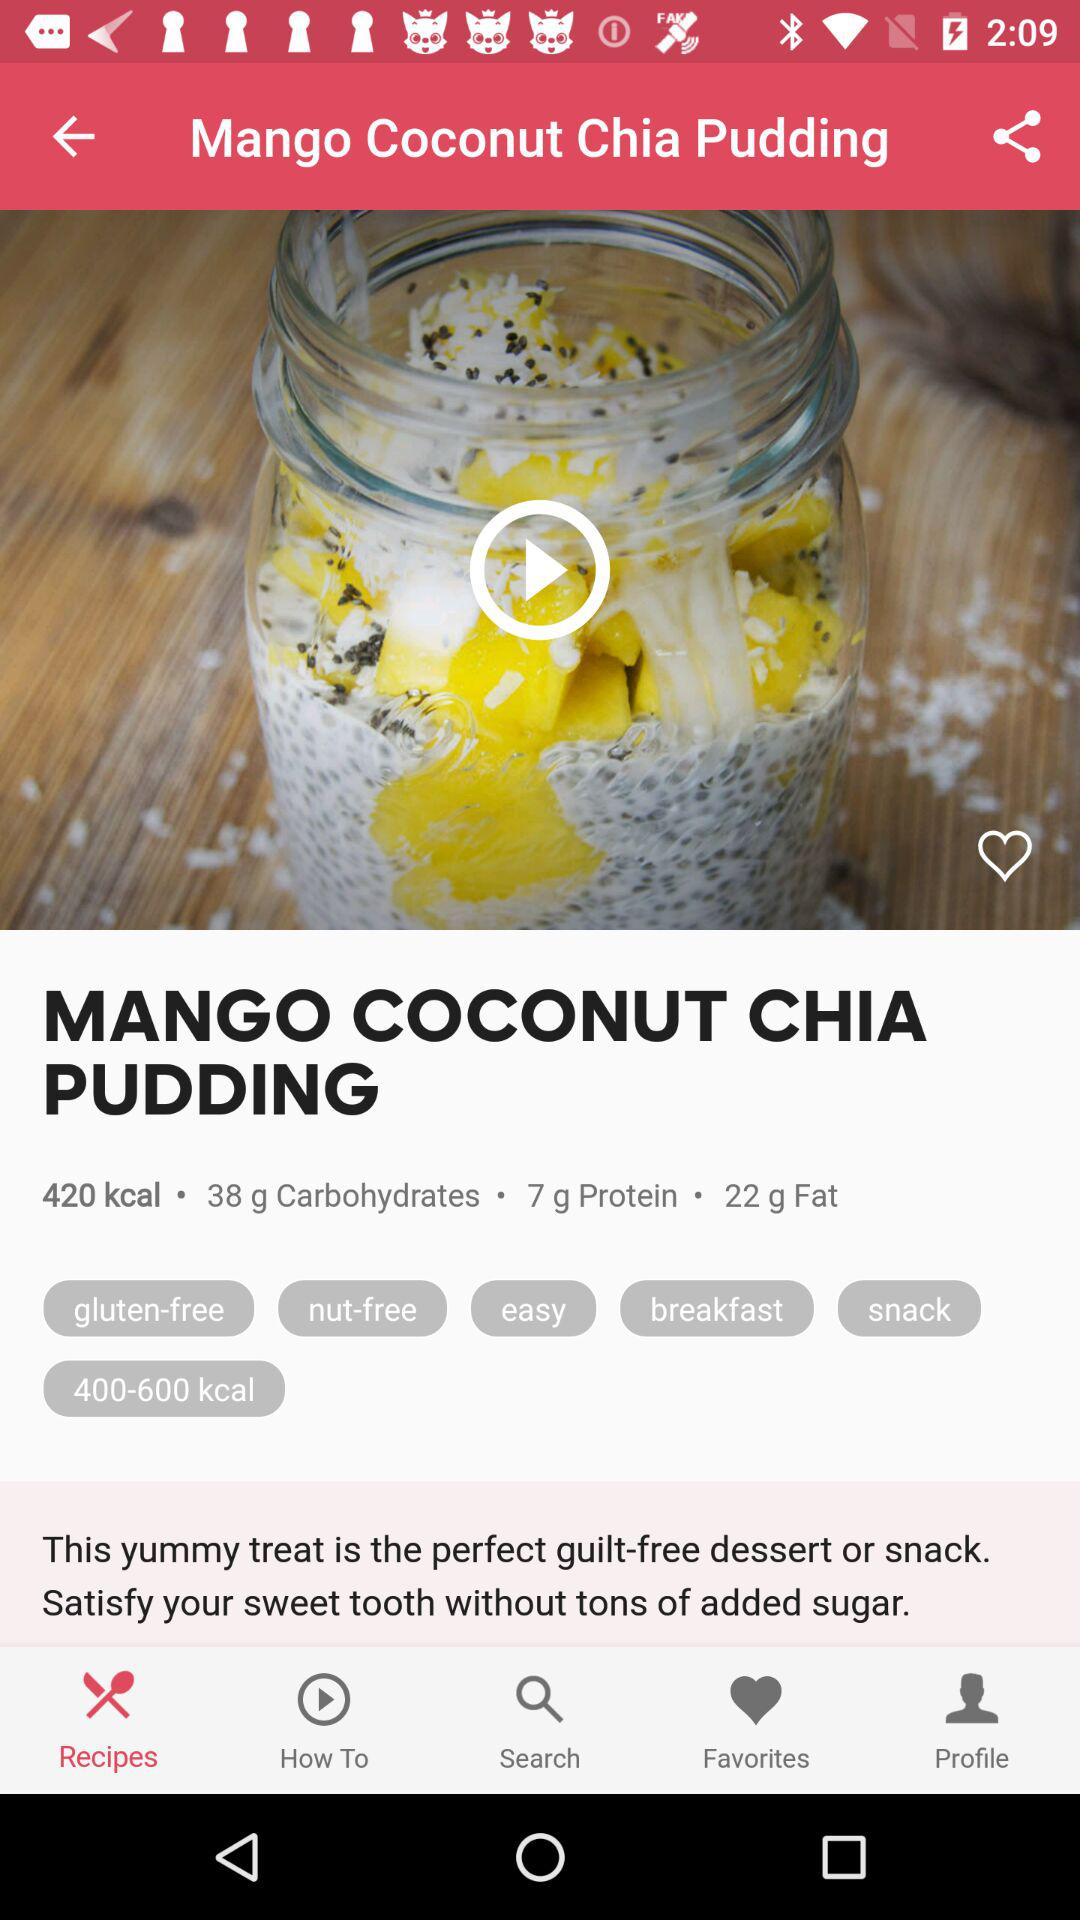How many carbs are in this recipe? 38 g 